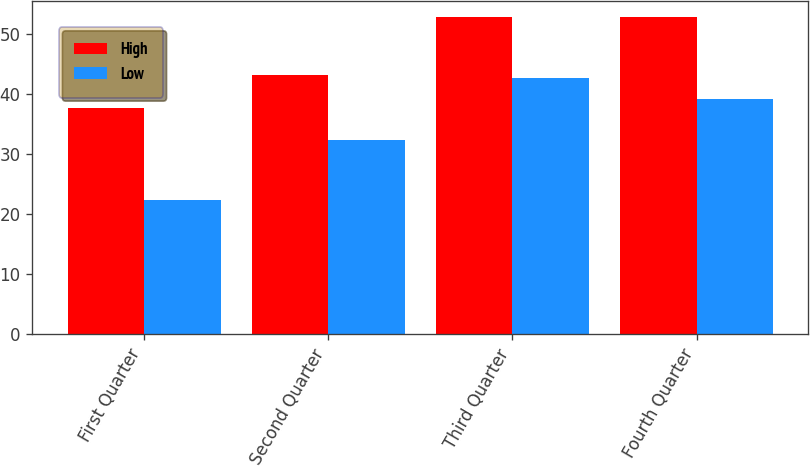<chart> <loc_0><loc_0><loc_500><loc_500><stacked_bar_chart><ecel><fcel>First Quarter<fcel>Second Quarter<fcel>Third Quarter<fcel>Fourth Quarter<nl><fcel>High<fcel>37.74<fcel>43.25<fcel>52.93<fcel>52.8<nl><fcel>Low<fcel>22.42<fcel>32.42<fcel>42.73<fcel>39.15<nl></chart> 